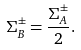Convert formula to latex. <formula><loc_0><loc_0><loc_500><loc_500>\Sigma _ { B } ^ { \pm } = \frac { \Sigma _ { A } ^ { \pm } } { 2 } .</formula> 